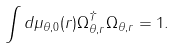<formula> <loc_0><loc_0><loc_500><loc_500>\int d \mu _ { \theta , 0 } ( r ) \Omega _ { \theta , r } ^ { \dagger } \Omega _ { \theta , r } = 1 .</formula> 